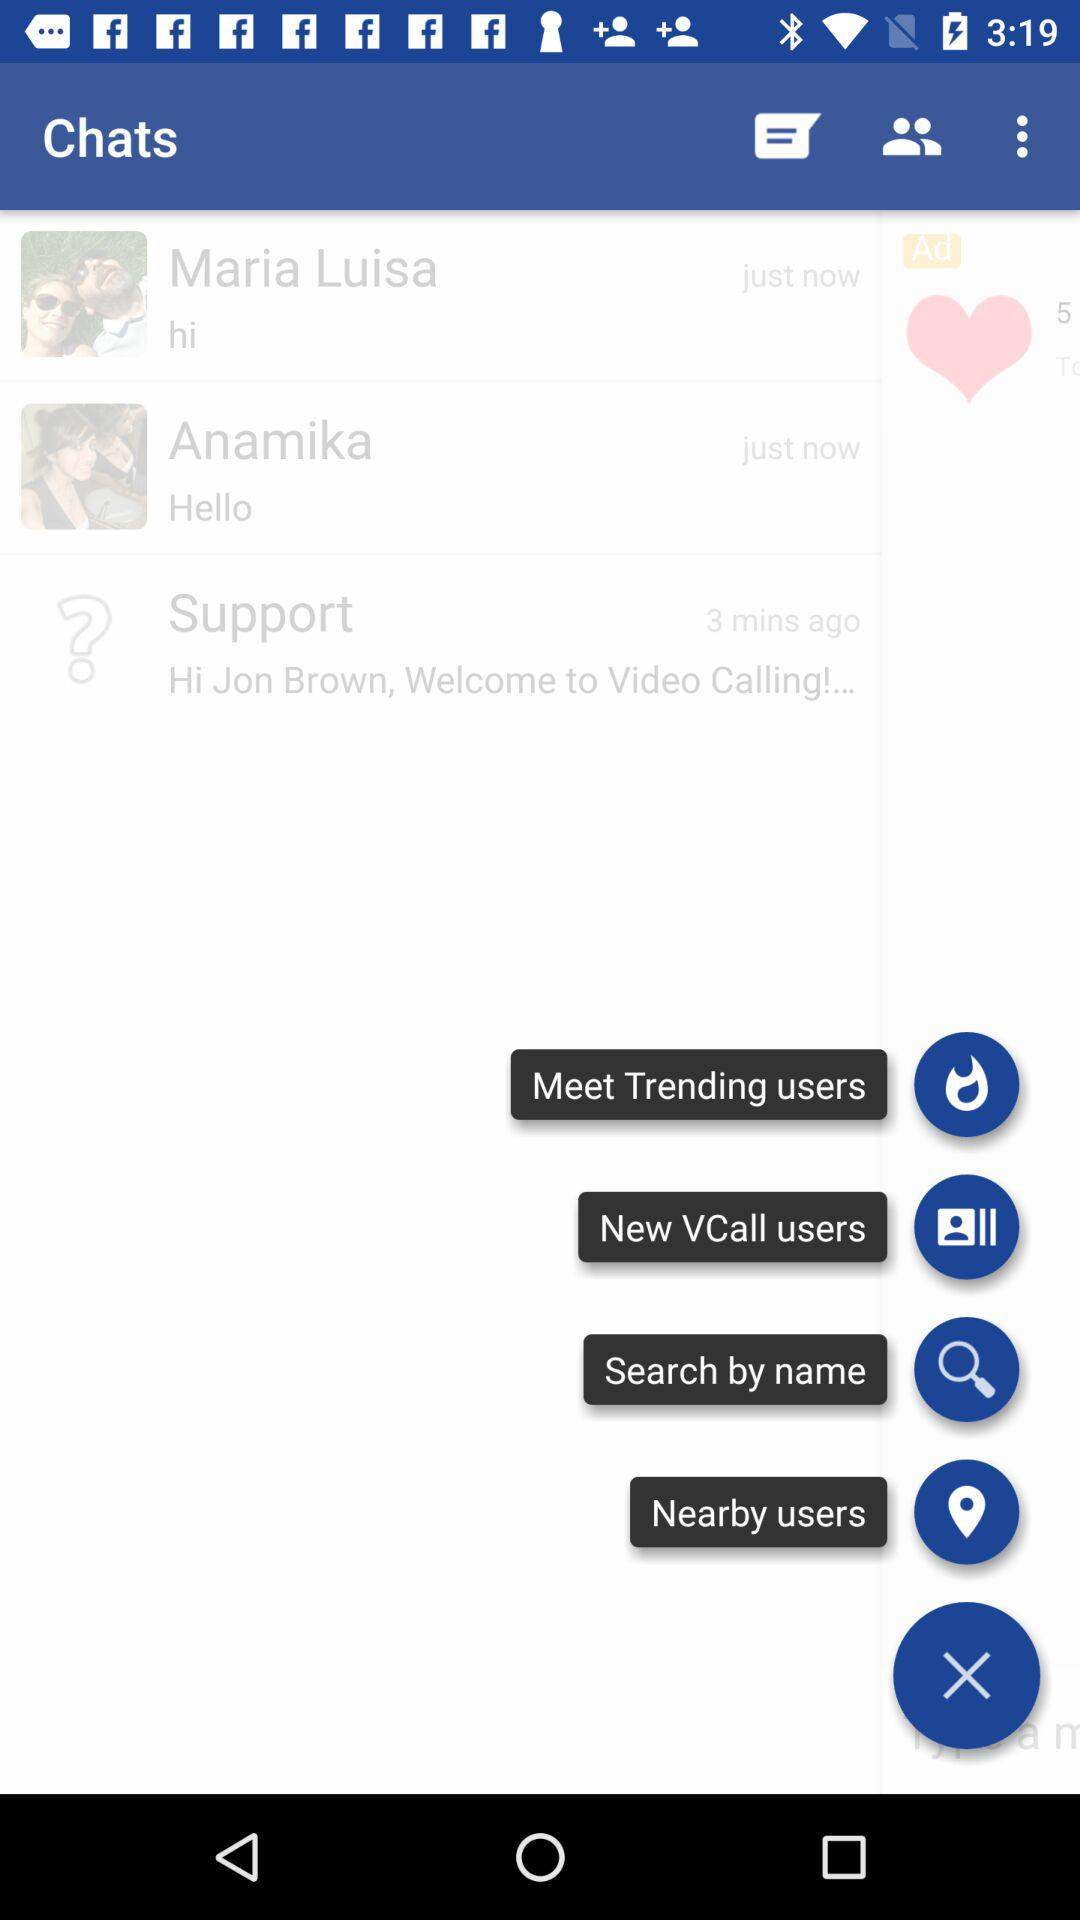What is the number of likes?
When the provided information is insufficient, respond with <no answer>. <no answer> 